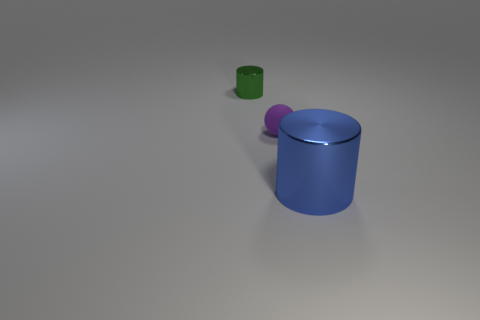Are there any small green metallic cylinders in front of the tiny ball?
Ensure brevity in your answer.  No. There is a rubber thing; does it have the same size as the metal cylinder behind the large object?
Offer a terse response. Yes. Is there a big shiny thing of the same color as the tiny matte thing?
Your response must be concise. No. Are there any other blue shiny objects that have the same shape as the large blue shiny object?
Offer a very short reply. No. The thing that is both on the right side of the tiny metallic cylinder and to the left of the big blue metal cylinder has what shape?
Make the answer very short. Sphere. How many tiny purple objects have the same material as the large cylinder?
Make the answer very short. 0. Is the number of blue shiny cylinders left of the small matte ball less than the number of green shiny things?
Offer a terse response. Yes. Is there a large blue metal cylinder to the left of the metallic cylinder that is left of the large metallic cylinder?
Make the answer very short. No. Is there any other thing that has the same shape as the blue thing?
Provide a short and direct response. Yes. Is the size of the green metallic cylinder the same as the matte ball?
Offer a terse response. Yes. 